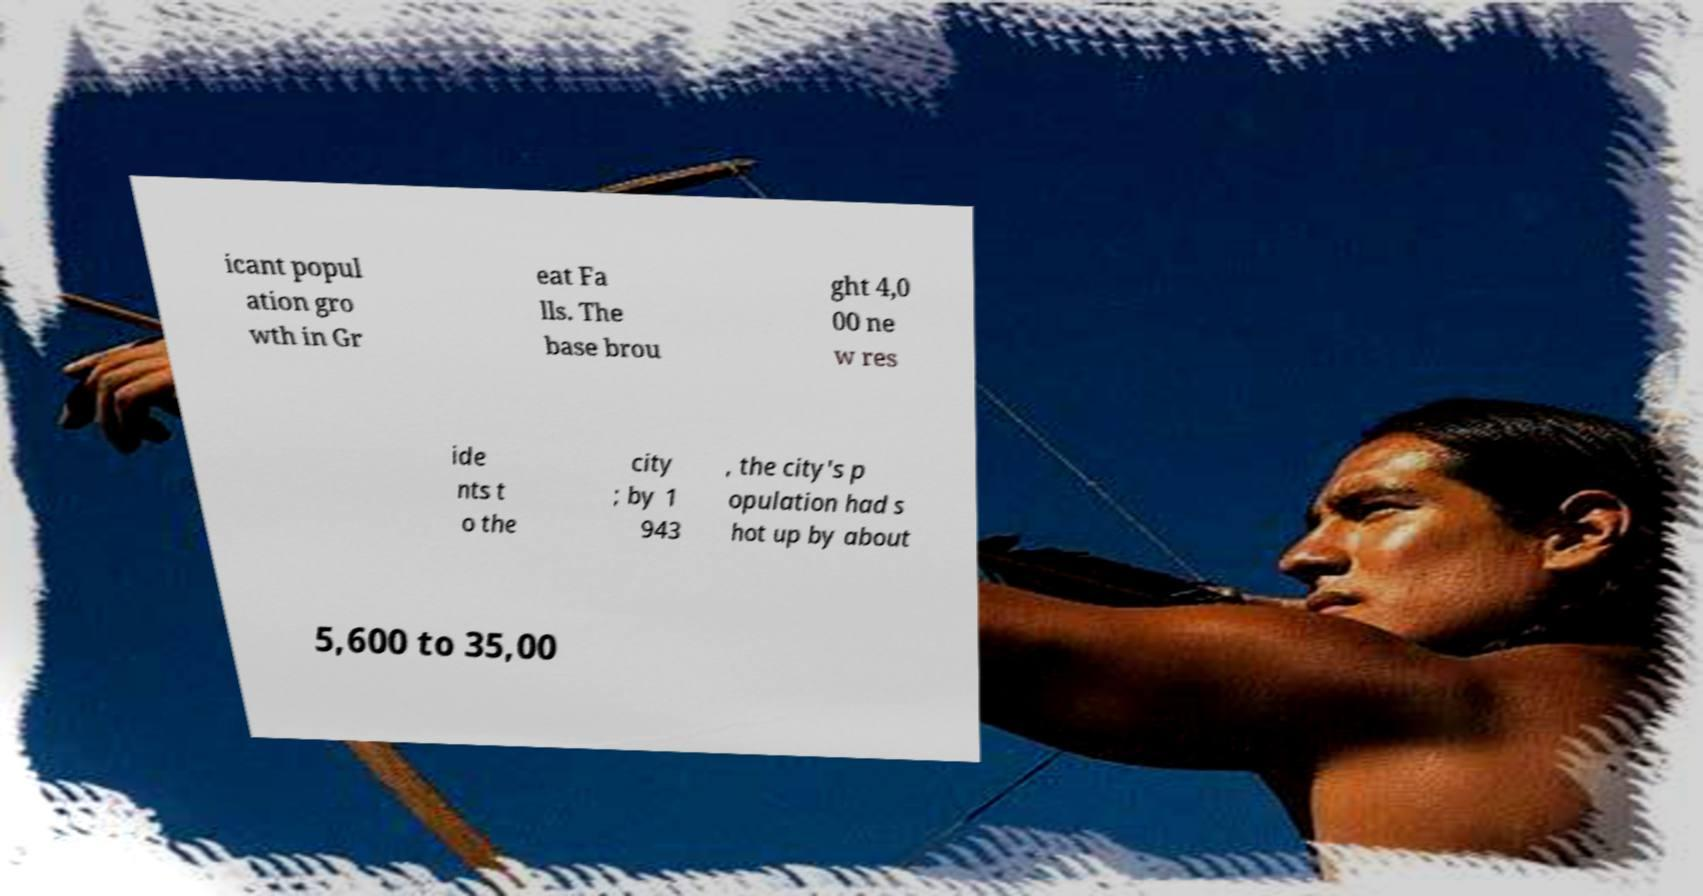Please identify and transcribe the text found in this image. icant popul ation gro wth in Gr eat Fa lls. The base brou ght 4,0 00 ne w res ide nts t o the city ; by 1 943 , the city's p opulation had s hot up by about 5,600 to 35,00 